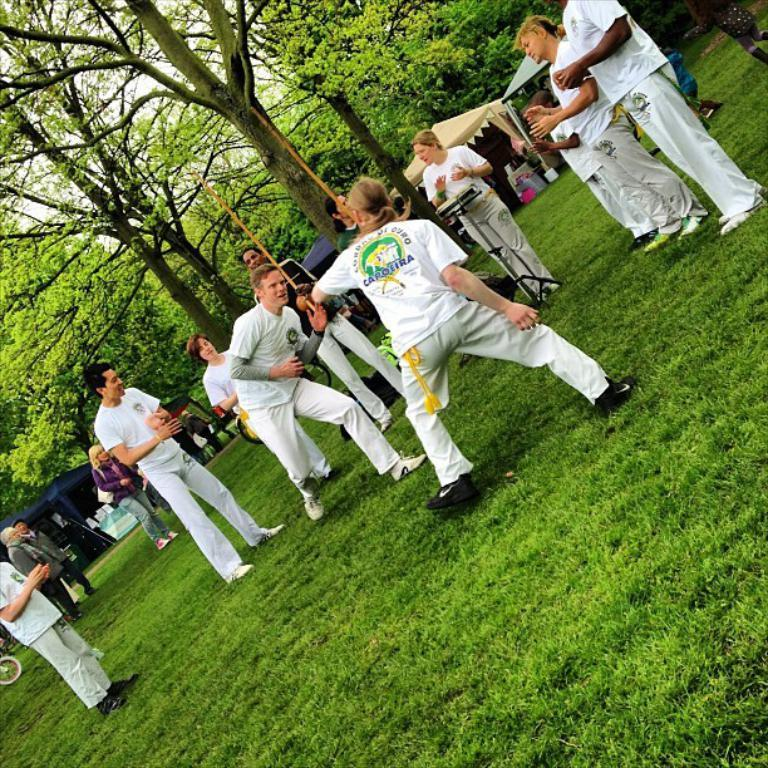How many people can be seen in the image? There are persons in the image, but the exact number is not specified. What type of temporary shelter is present in the image? There are tents in the image. What mode of transportation can be seen in the image? There are bicycles in the image. What structure is present in the image that might be used for displaying or selling items? There is a stand in the image. What type of signage or information boards are present in the image? There are boards in the image. What type of natural vegetation is visible at the top of the image? Trees are visible at the top of the image. What type of surface is visible at the bottom of the image? The ground is visible at the bottom of the image. Can you see a crown on any of the persons in the image? There is no mention of a crown in the image, so it cannot be confirmed or denied. What type of liquid is being sold or displayed at the stand in the image? There is no mention of any liquid in the image, so it cannot be confirmed or denied. 